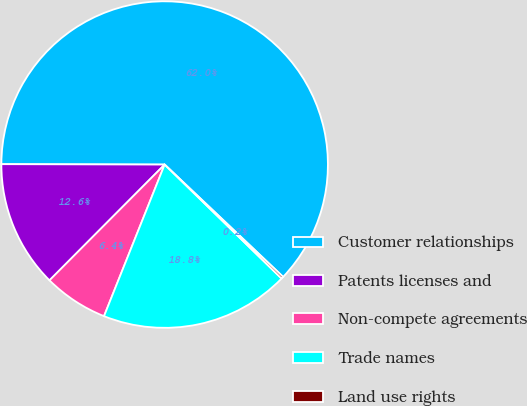<chart> <loc_0><loc_0><loc_500><loc_500><pie_chart><fcel>Customer relationships<fcel>Patents licenses and<fcel>Non-compete agreements<fcel>Trade names<fcel>Land use rights<nl><fcel>62.03%<fcel>12.58%<fcel>6.4%<fcel>18.76%<fcel>0.22%<nl></chart> 